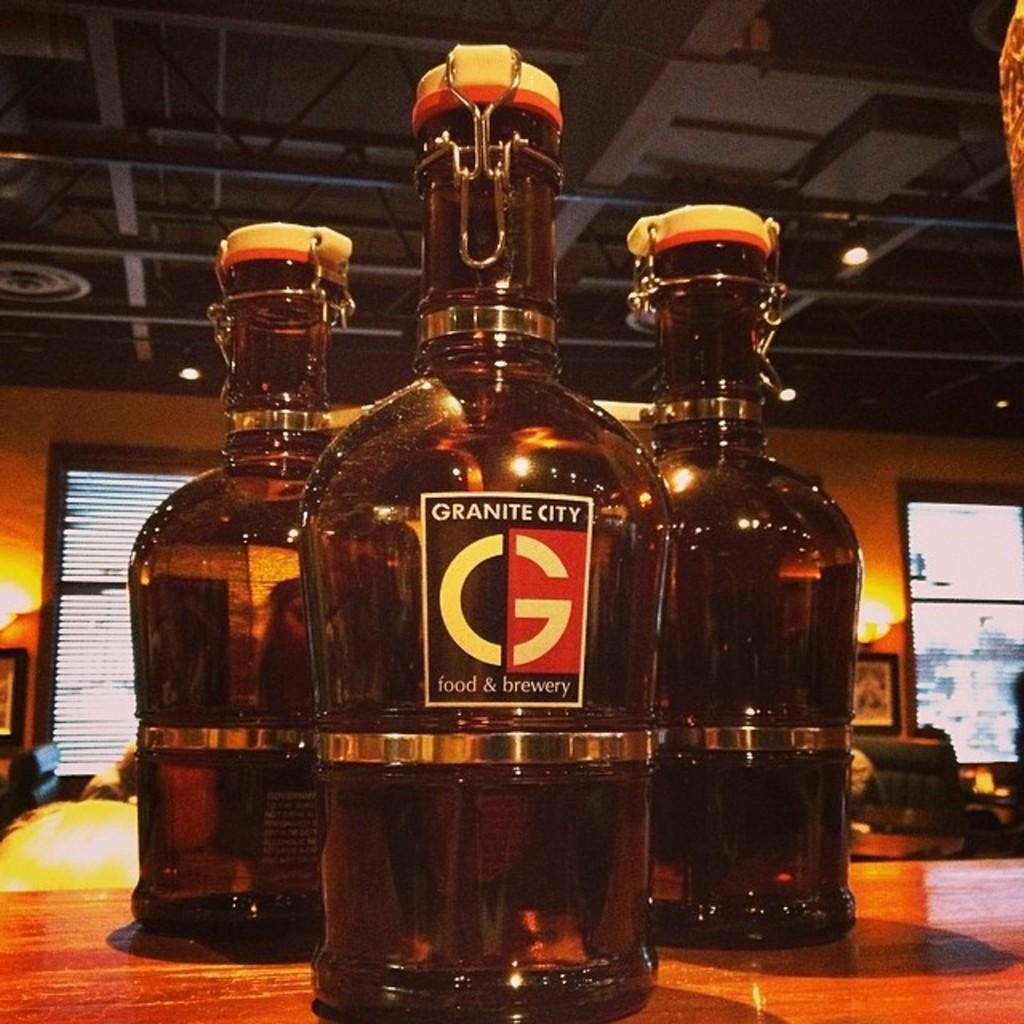<image>
Relay a brief, clear account of the picture shown. Three oversized serving bottles with "Granite City food & brewery" printed on the label sitting on a counter. 